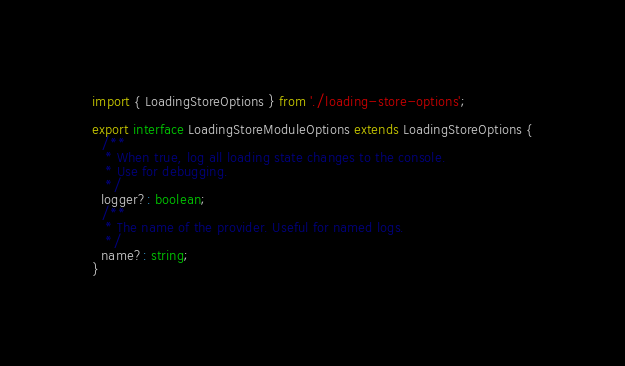<code> <loc_0><loc_0><loc_500><loc_500><_TypeScript_>import { LoadingStoreOptions } from './loading-store-options';

export interface LoadingStoreModuleOptions extends LoadingStoreOptions {
  /**
   * When true, log all loading state changes to the console.
   * Use for debugging.
   */
  logger?: boolean;
  /**
   * The name of the provider. Useful for named logs.
   */
  name?: string;
}
</code> 